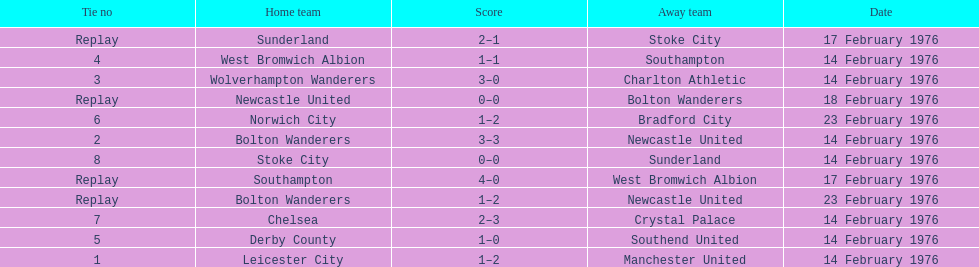Which teams played the same day as leicester city and manchester united? Bolton Wanderers, Newcastle United. Would you be able to parse every entry in this table? {'header': ['Tie no', 'Home team', 'Score', 'Away team', 'Date'], 'rows': [['Replay', 'Sunderland', '2–1', 'Stoke City', '17 February 1976'], ['4', 'West Bromwich Albion', '1–1', 'Southampton', '14 February 1976'], ['3', 'Wolverhampton Wanderers', '3–0', 'Charlton Athletic', '14 February 1976'], ['Replay', 'Newcastle United', '0–0', 'Bolton Wanderers', '18 February 1976'], ['6', 'Norwich City', '1–2', 'Bradford City', '23 February 1976'], ['2', 'Bolton Wanderers', '3–3', 'Newcastle United', '14 February 1976'], ['8', 'Stoke City', '0–0', 'Sunderland', '14 February 1976'], ['Replay', 'Southampton', '4–0', 'West Bromwich Albion', '17 February 1976'], ['Replay', 'Bolton Wanderers', '1–2', 'Newcastle United', '23 February 1976'], ['7', 'Chelsea', '2–3', 'Crystal Palace', '14 February 1976'], ['5', 'Derby County', '1–0', 'Southend United', '14 February 1976'], ['1', 'Leicester City', '1–2', 'Manchester United', '14 February 1976']]} 